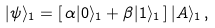<formula> <loc_0><loc_0><loc_500><loc_500>| \psi \rangle _ { 1 } = [ \, \alpha | 0 \rangle _ { 1 } + \beta | 1 \rangle _ { 1 } \, ] \, | A \rangle _ { 1 } \, ,</formula> 